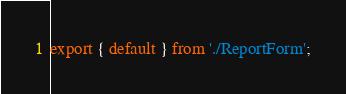Convert code to text. <code><loc_0><loc_0><loc_500><loc_500><_JavaScript_>export { default } from './ReportForm';</code> 